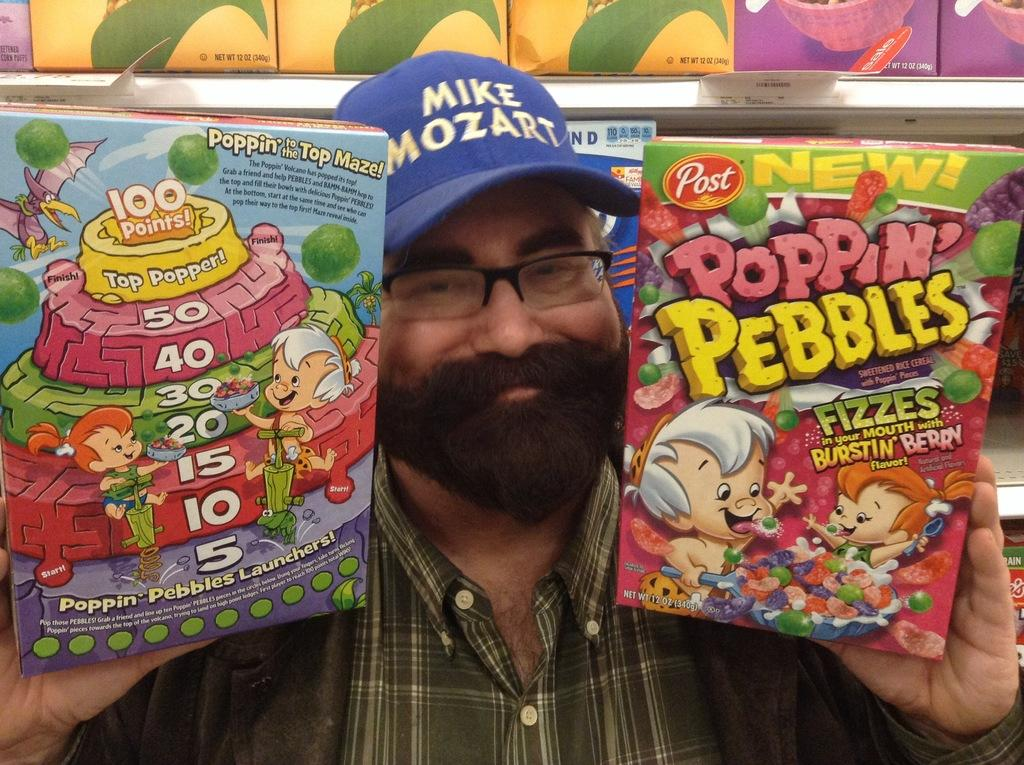Who is present in the image? There is a man in the picture. What is the man wearing on his head? The man is wearing a cap. What type of eyewear is the man wearing? The man is wearing spectacles. What is the man wearing on his upper body? The man is wearing a shirt and a jacket. What is the man holding in his hands? The man is holding two boxes. What can be seen in the background of the image? There are many boxes on racks in the background of the image. What type of agreement does the man have with his mother in the image? There is no mention of a mother or any agreement in the image; it only features a man holding two boxes and many boxes on racks in the background. 